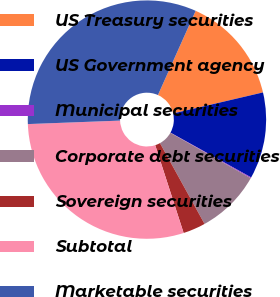<chart> <loc_0><loc_0><loc_500><loc_500><pie_chart><fcel>US Treasury securities<fcel>US Government agency<fcel>Municipal securities<fcel>Corporate debt securities<fcel>Sovereign securities<fcel>Subtotal<fcel>Marketable securities<nl><fcel>14.64%<fcel>11.72%<fcel>0.12%<fcel>8.79%<fcel>3.05%<fcel>29.38%<fcel>32.3%<nl></chart> 